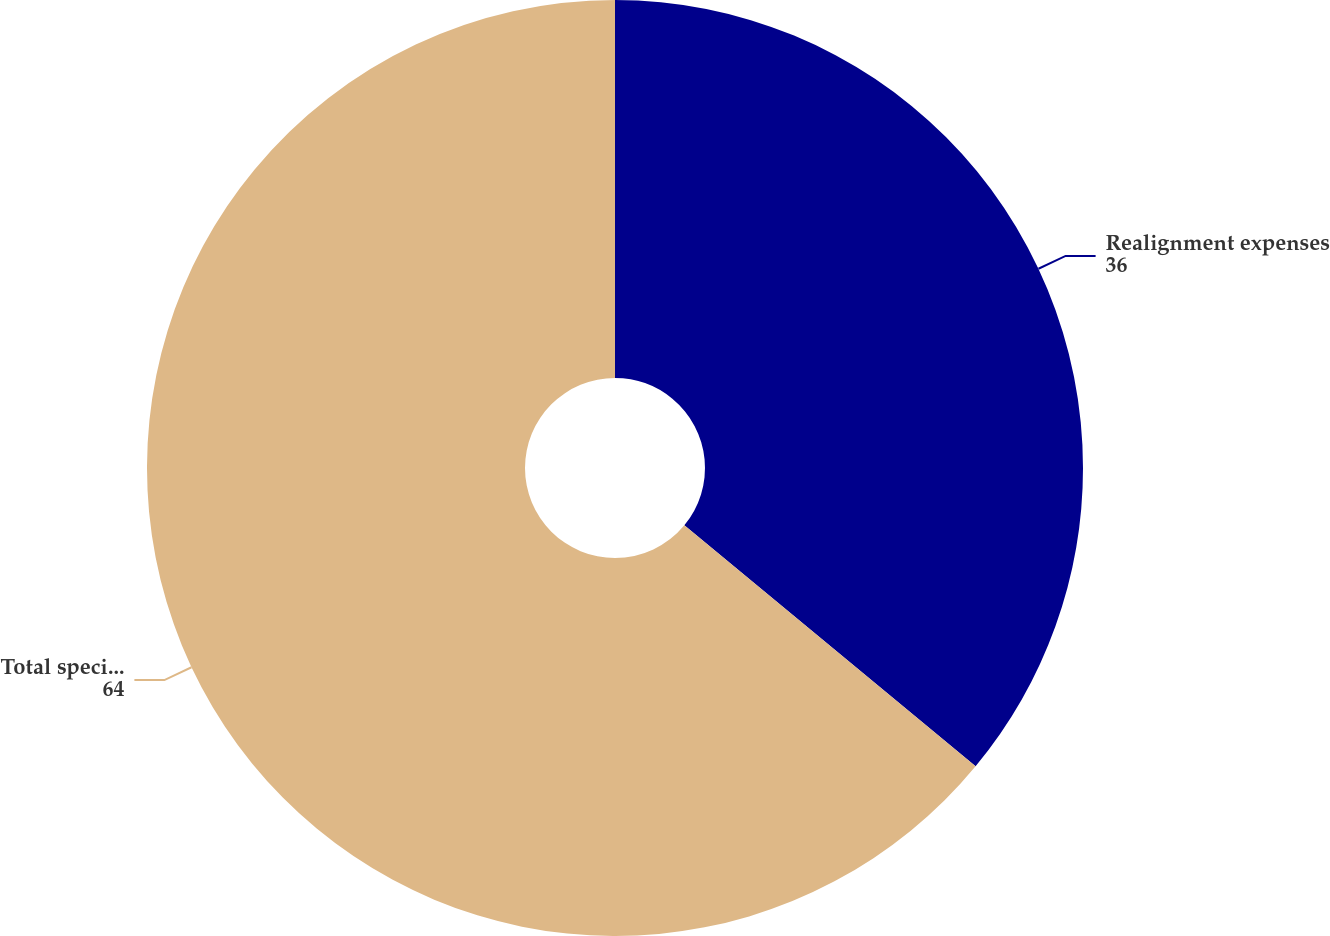Convert chart. <chart><loc_0><loc_0><loc_500><loc_500><pie_chart><fcel>Realignment expenses<fcel>Total special (gains) charges<nl><fcel>36.0%<fcel>64.0%<nl></chart> 